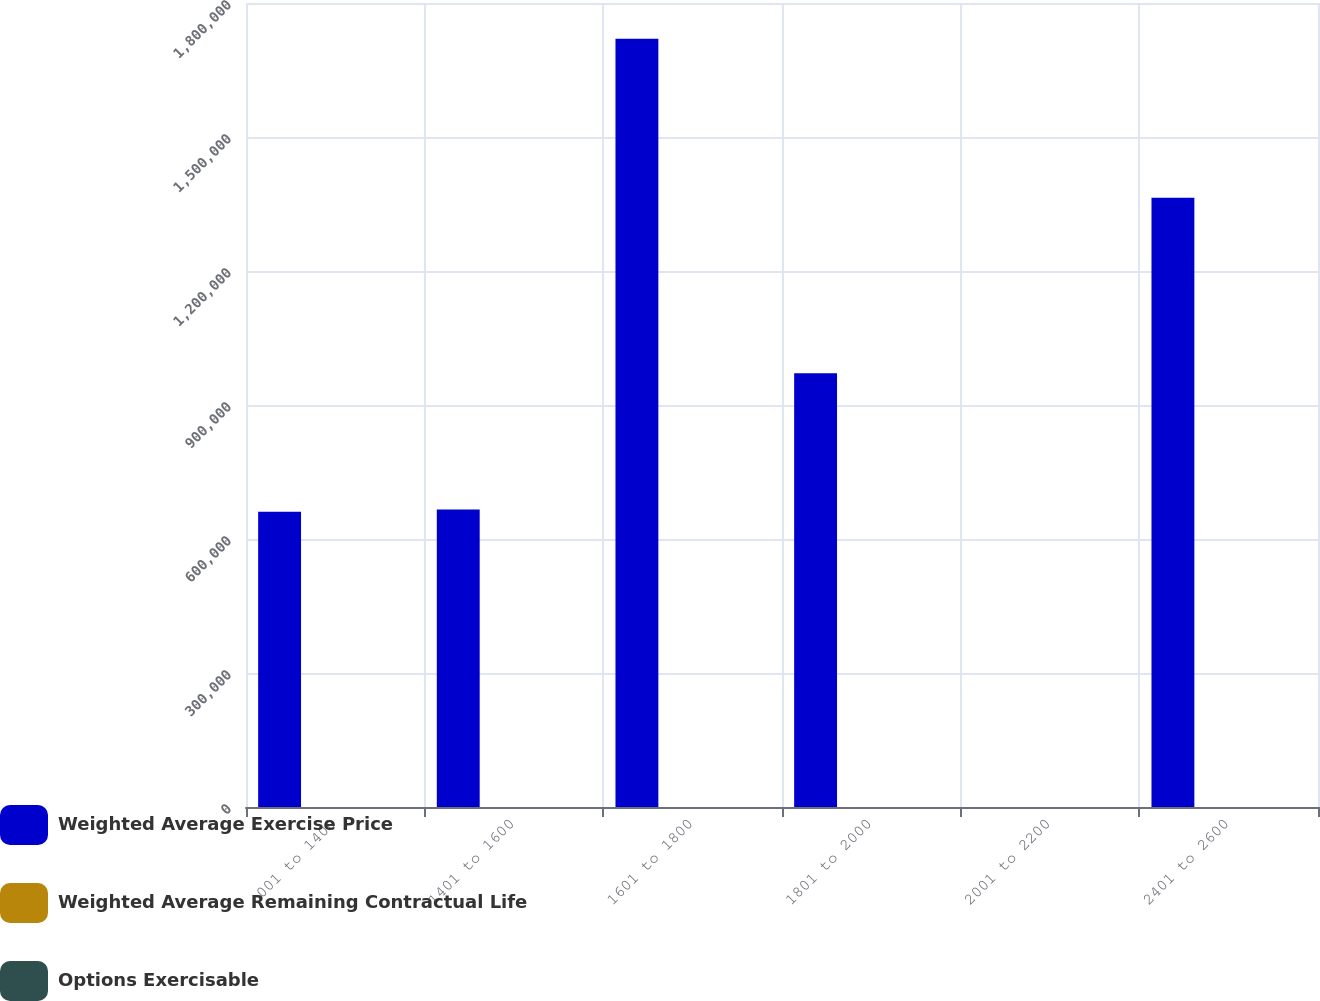Convert chart. <chart><loc_0><loc_0><loc_500><loc_500><stacked_bar_chart><ecel><fcel>001 to 1400<fcel>1401 to 1600<fcel>1601 to 1800<fcel>1801 to 2000<fcel>2001 to 2200<fcel>2401 to 2600<nl><fcel>Weighted Average Exercise Price<fcel>660980<fcel>666306<fcel>1.72008e+06<fcel>970965<fcel>17.6<fcel>1.36403e+06<nl><fcel>Weighted Average Remaining Contractual Life<fcel>4.97<fcel>5.15<fcel>4.95<fcel>7.4<fcel>4.12<fcel>3.3<nl><fcel>Options Exercisable<fcel>13.5<fcel>15.85<fcel>17.6<fcel>18.67<fcel>20.63<fcel>24.39<nl></chart> 